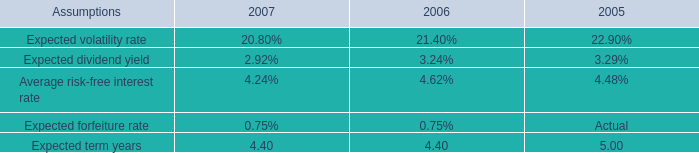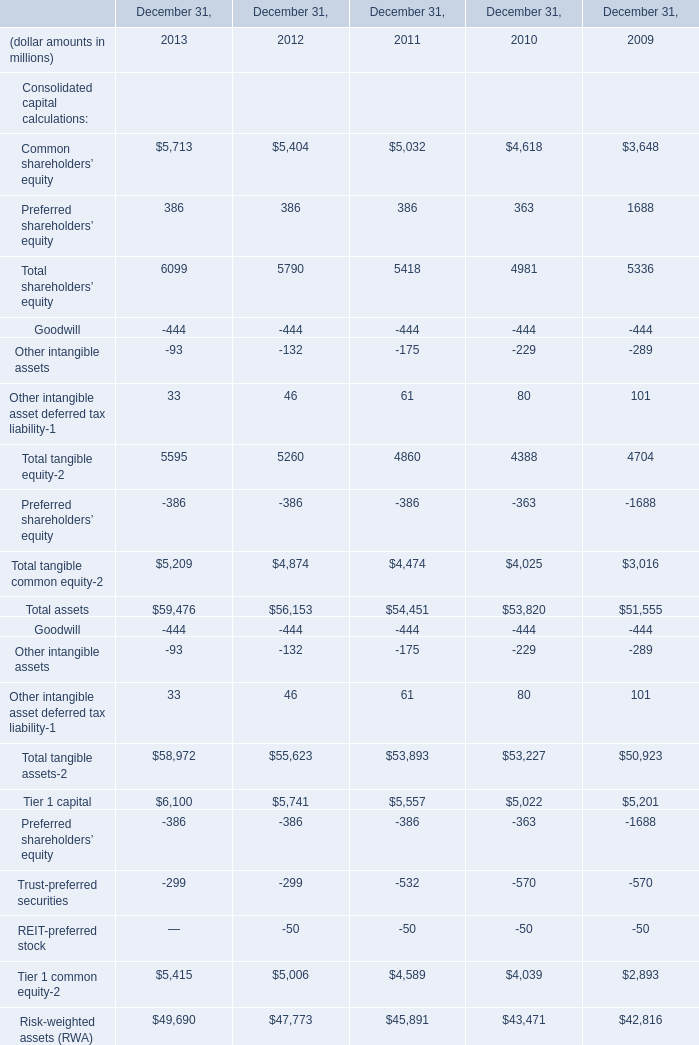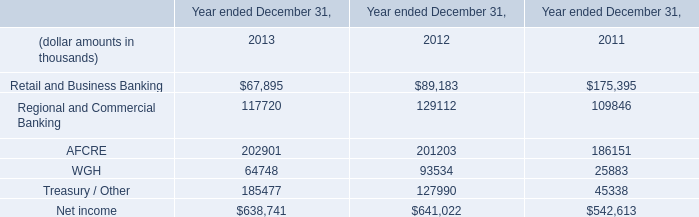What's the average of WGH of Year ended December 31, 2013, and Tier 1 capital of December 31, 2011 ? 
Computations: ((64748.0 + 5557.0) / 2)
Answer: 35152.5. 